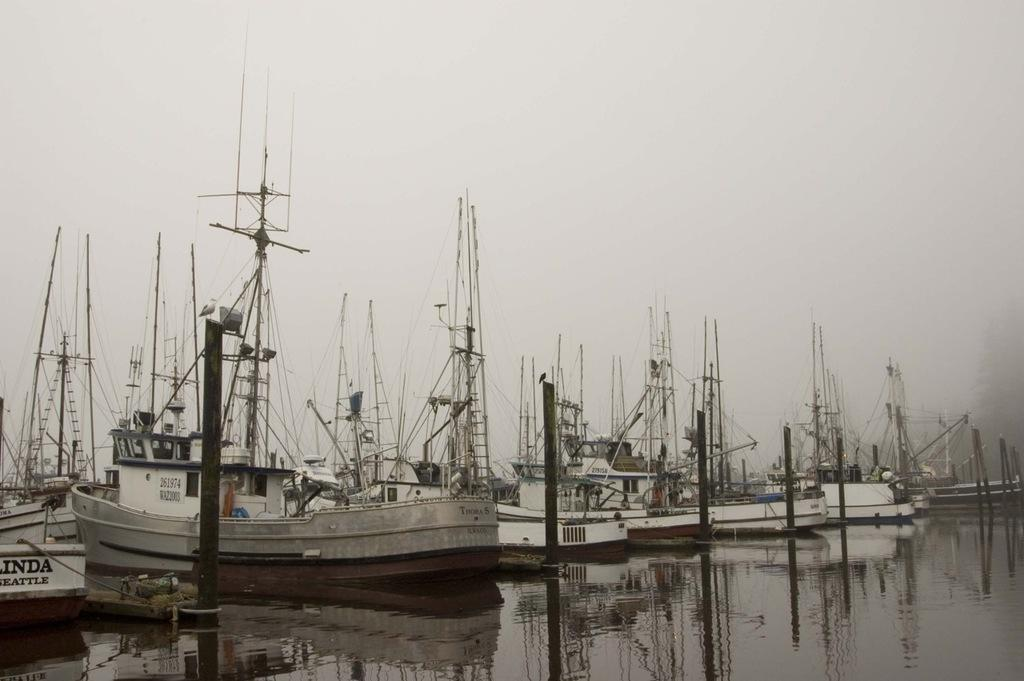<image>
Present a compact description of the photo's key features. Ships from Seattle are docked in the water near each other. 